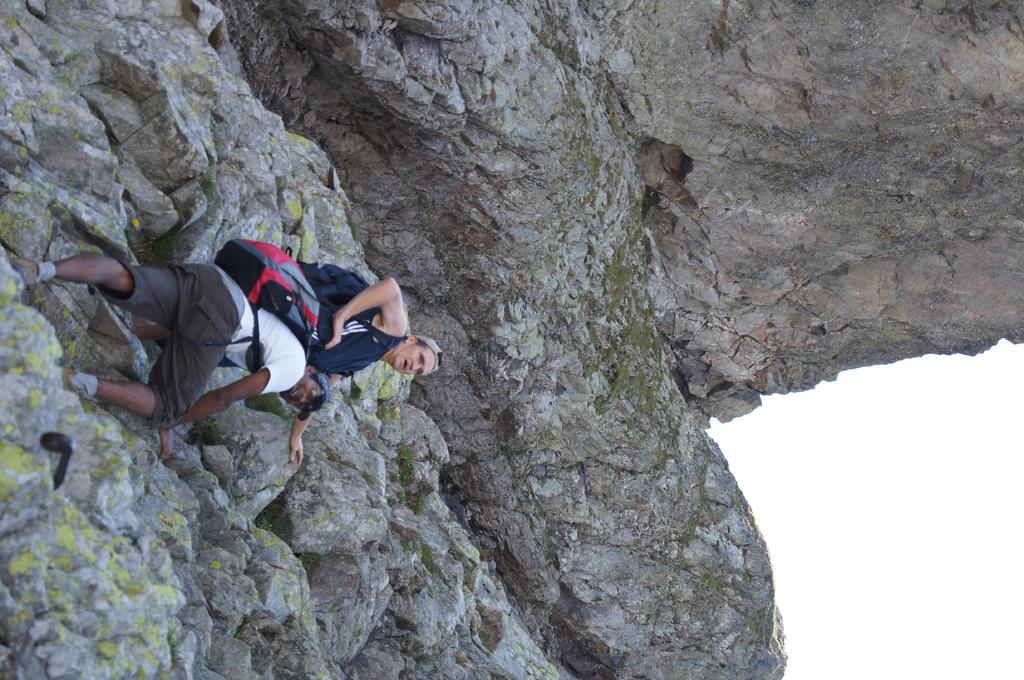How many people are in the image? There are two men in the image. What are the men doing in the image? The men are climbing a stone mountain. What are the men wearing that might be used for carrying items? The men are wearing bags. What part of the sky can be seen in the image? The sky is visible in the bottom right corner of the image. What type of appliance can be seen in the image? There is no appliance present in the image. Who is the manager of the climbing expedition in the image? There is no indication of a manager or climbing expedition in the image. 